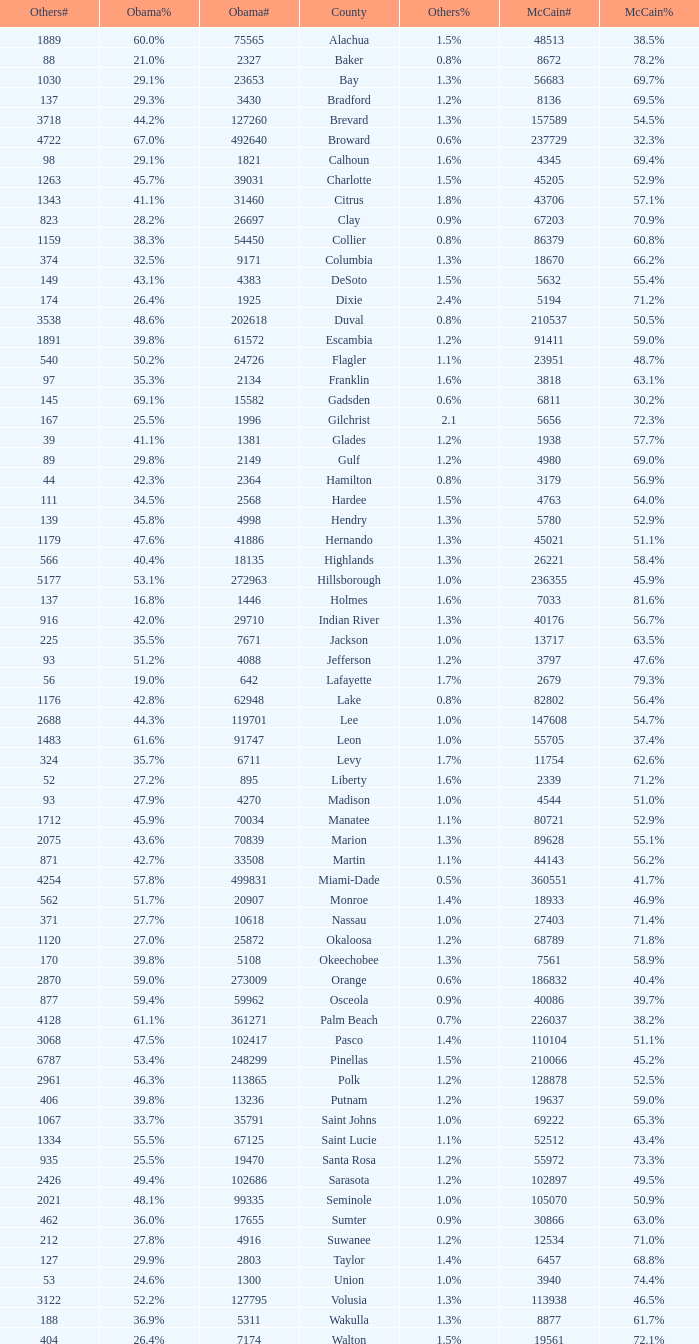What was the number of others votes in Columbia county? 374.0. 